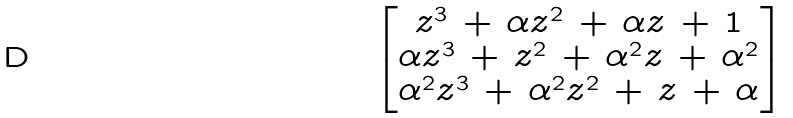<formula> <loc_0><loc_0><loc_500><loc_500>\begin{bmatrix} z ^ { 3 } \, + \, \alpha z ^ { 2 } \, + \, \alpha z \, + \, 1 \\ \alpha z ^ { 3 } \, + \, z ^ { 2 } \, + \, \alpha ^ { 2 } z \, + \, \alpha ^ { 2 } \\ \alpha ^ { 2 } z ^ { 3 } \, + \, \alpha ^ { 2 } z ^ { 2 } \, + \, z \, + \, \alpha \end{bmatrix}</formula> 